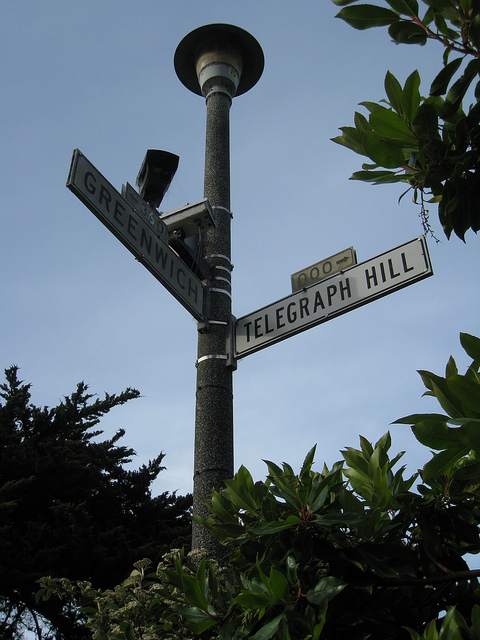Please extract the text content from this image. TELEGRAPH HILL GREENWICH 000 